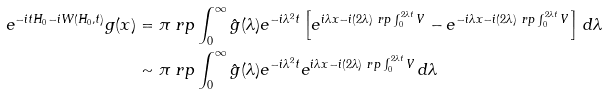Convert formula to latex. <formula><loc_0><loc_0><loc_500><loc_500>e ^ { - i t H _ { 0 } - i W ( H _ { 0 } , t ) } g ( x ) & = \pi \ r p \int _ { 0 } ^ { \infty } \hat { g } ( \lambda ) e ^ { - i \lambda ^ { 2 } t } \left [ e ^ { i \lambda x - i ( 2 \lambda ) \ r p \int _ { 0 } ^ { 2 \lambda t } V } - e ^ { - i \lambda x - i ( 2 \lambda ) \ r p \int _ { 0 } ^ { 2 \lambda t } V } \right ] \, d \lambda \\ & \sim \pi \ r p \int _ { 0 } ^ { \infty } \hat { g } ( \lambda ) e ^ { - i \lambda ^ { 2 } t } e ^ { i \lambda x - i ( 2 \lambda ) \ r p \int _ { 0 } ^ { 2 \lambda t } V } \, d \lambda</formula> 